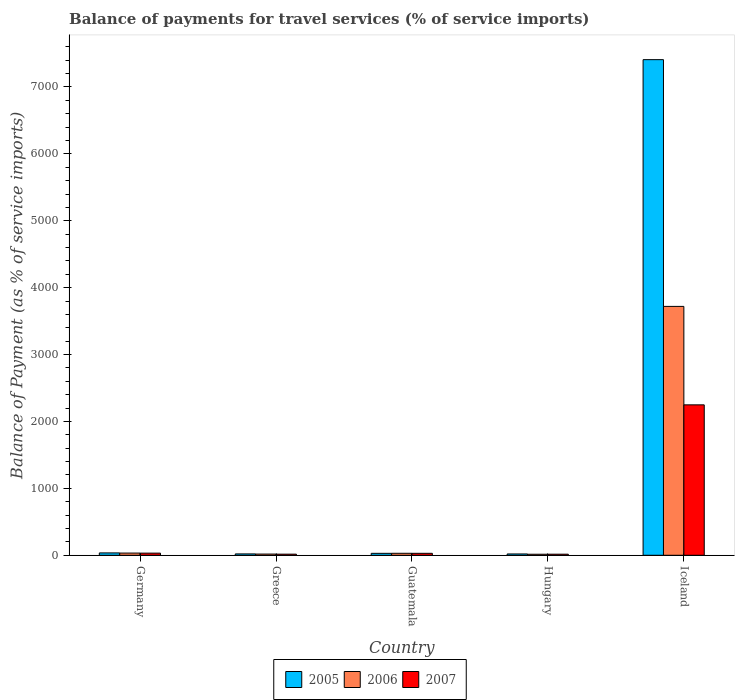How many different coloured bars are there?
Your response must be concise. 3. Are the number of bars per tick equal to the number of legend labels?
Make the answer very short. Yes. How many bars are there on the 1st tick from the right?
Your response must be concise. 3. What is the label of the 3rd group of bars from the left?
Your response must be concise. Guatemala. What is the balance of payments for travel services in 2005 in Germany?
Ensure brevity in your answer.  35.35. Across all countries, what is the maximum balance of payments for travel services in 2005?
Your response must be concise. 7408.18. Across all countries, what is the minimum balance of payments for travel services in 2005?
Your answer should be very brief. 19.74. In which country was the balance of payments for travel services in 2005 minimum?
Your answer should be very brief. Hungary. What is the total balance of payments for travel services in 2007 in the graph?
Your answer should be compact. 2342.43. What is the difference between the balance of payments for travel services in 2005 in Hungary and that in Iceland?
Offer a terse response. -7388.44. What is the difference between the balance of payments for travel services in 2005 in Iceland and the balance of payments for travel services in 2006 in Germany?
Your response must be concise. 7375.24. What is the average balance of payments for travel services in 2006 per country?
Ensure brevity in your answer.  763.21. What is the difference between the balance of payments for travel services of/in 2007 and balance of payments for travel services of/in 2006 in Germany?
Give a very brief answer. -0.89. What is the ratio of the balance of payments for travel services in 2005 in Greece to that in Iceland?
Provide a short and direct response. 0. Is the difference between the balance of payments for travel services in 2007 in Germany and Guatemala greater than the difference between the balance of payments for travel services in 2006 in Germany and Guatemala?
Keep it short and to the point. No. What is the difference between the highest and the second highest balance of payments for travel services in 2007?
Give a very brief answer. 2216.37. What is the difference between the highest and the lowest balance of payments for travel services in 2007?
Make the answer very short. 2232.34. What does the 2nd bar from the left in Germany represents?
Your answer should be compact. 2006. Is it the case that in every country, the sum of the balance of payments for travel services in 2006 and balance of payments for travel services in 2005 is greater than the balance of payments for travel services in 2007?
Ensure brevity in your answer.  Yes. How many bars are there?
Ensure brevity in your answer.  15. Are all the bars in the graph horizontal?
Make the answer very short. No. How many countries are there in the graph?
Offer a very short reply. 5. Are the values on the major ticks of Y-axis written in scientific E-notation?
Offer a terse response. No. Does the graph contain any zero values?
Your answer should be very brief. No. How many legend labels are there?
Offer a very short reply. 3. What is the title of the graph?
Make the answer very short. Balance of payments for travel services (% of service imports). What is the label or title of the X-axis?
Keep it short and to the point. Country. What is the label or title of the Y-axis?
Provide a short and direct response. Balance of Payment (as % of service imports). What is the Balance of Payment (as % of service imports) in 2005 in Germany?
Your answer should be compact. 35.35. What is the Balance of Payment (as % of service imports) of 2006 in Germany?
Provide a succinct answer. 32.95. What is the Balance of Payment (as % of service imports) in 2007 in Germany?
Ensure brevity in your answer.  32.05. What is the Balance of Payment (as % of service imports) of 2005 in Greece?
Provide a succinct answer. 20.38. What is the Balance of Payment (as % of service imports) of 2006 in Greece?
Your response must be concise. 17.89. What is the Balance of Payment (as % of service imports) in 2007 in Greece?
Ensure brevity in your answer.  16.62. What is the Balance of Payment (as % of service imports) in 2005 in Guatemala?
Keep it short and to the point. 29.03. What is the Balance of Payment (as % of service imports) of 2006 in Guatemala?
Your response must be concise. 29.72. What is the Balance of Payment (as % of service imports) in 2007 in Guatemala?
Offer a terse response. 29.26. What is the Balance of Payment (as % of service imports) in 2005 in Hungary?
Your answer should be very brief. 19.74. What is the Balance of Payment (as % of service imports) in 2006 in Hungary?
Provide a short and direct response. 15.47. What is the Balance of Payment (as % of service imports) of 2007 in Hungary?
Make the answer very short. 16.08. What is the Balance of Payment (as % of service imports) of 2005 in Iceland?
Provide a short and direct response. 7408.18. What is the Balance of Payment (as % of service imports) in 2006 in Iceland?
Keep it short and to the point. 3720.04. What is the Balance of Payment (as % of service imports) of 2007 in Iceland?
Give a very brief answer. 2248.42. Across all countries, what is the maximum Balance of Payment (as % of service imports) of 2005?
Your answer should be very brief. 7408.18. Across all countries, what is the maximum Balance of Payment (as % of service imports) of 2006?
Provide a succinct answer. 3720.04. Across all countries, what is the maximum Balance of Payment (as % of service imports) in 2007?
Provide a short and direct response. 2248.42. Across all countries, what is the minimum Balance of Payment (as % of service imports) in 2005?
Ensure brevity in your answer.  19.74. Across all countries, what is the minimum Balance of Payment (as % of service imports) in 2006?
Your response must be concise. 15.47. Across all countries, what is the minimum Balance of Payment (as % of service imports) of 2007?
Your answer should be compact. 16.08. What is the total Balance of Payment (as % of service imports) of 2005 in the graph?
Your answer should be compact. 7512.68. What is the total Balance of Payment (as % of service imports) of 2006 in the graph?
Offer a very short reply. 3816.07. What is the total Balance of Payment (as % of service imports) in 2007 in the graph?
Offer a very short reply. 2342.43. What is the difference between the Balance of Payment (as % of service imports) of 2005 in Germany and that in Greece?
Your answer should be very brief. 14.97. What is the difference between the Balance of Payment (as % of service imports) in 2006 in Germany and that in Greece?
Offer a terse response. 15.06. What is the difference between the Balance of Payment (as % of service imports) in 2007 in Germany and that in Greece?
Your response must be concise. 15.44. What is the difference between the Balance of Payment (as % of service imports) in 2005 in Germany and that in Guatemala?
Provide a succinct answer. 6.32. What is the difference between the Balance of Payment (as % of service imports) in 2006 in Germany and that in Guatemala?
Provide a short and direct response. 3.23. What is the difference between the Balance of Payment (as % of service imports) of 2007 in Germany and that in Guatemala?
Provide a succinct answer. 2.8. What is the difference between the Balance of Payment (as % of service imports) of 2005 in Germany and that in Hungary?
Provide a short and direct response. 15.61. What is the difference between the Balance of Payment (as % of service imports) in 2006 in Germany and that in Hungary?
Make the answer very short. 17.47. What is the difference between the Balance of Payment (as % of service imports) in 2007 in Germany and that in Hungary?
Offer a terse response. 15.97. What is the difference between the Balance of Payment (as % of service imports) of 2005 in Germany and that in Iceland?
Provide a succinct answer. -7372.83. What is the difference between the Balance of Payment (as % of service imports) in 2006 in Germany and that in Iceland?
Provide a short and direct response. -3687.1. What is the difference between the Balance of Payment (as % of service imports) of 2007 in Germany and that in Iceland?
Your response must be concise. -2216.37. What is the difference between the Balance of Payment (as % of service imports) in 2005 in Greece and that in Guatemala?
Keep it short and to the point. -8.65. What is the difference between the Balance of Payment (as % of service imports) in 2006 in Greece and that in Guatemala?
Your answer should be compact. -11.83. What is the difference between the Balance of Payment (as % of service imports) in 2007 in Greece and that in Guatemala?
Give a very brief answer. -12.64. What is the difference between the Balance of Payment (as % of service imports) in 2005 in Greece and that in Hungary?
Your answer should be compact. 0.64. What is the difference between the Balance of Payment (as % of service imports) of 2006 in Greece and that in Hungary?
Keep it short and to the point. 2.41. What is the difference between the Balance of Payment (as % of service imports) in 2007 in Greece and that in Hungary?
Your answer should be compact. 0.54. What is the difference between the Balance of Payment (as % of service imports) in 2005 in Greece and that in Iceland?
Your response must be concise. -7387.81. What is the difference between the Balance of Payment (as % of service imports) in 2006 in Greece and that in Iceland?
Your response must be concise. -3702.16. What is the difference between the Balance of Payment (as % of service imports) of 2007 in Greece and that in Iceland?
Your answer should be compact. -2231.81. What is the difference between the Balance of Payment (as % of service imports) in 2005 in Guatemala and that in Hungary?
Provide a short and direct response. 9.29. What is the difference between the Balance of Payment (as % of service imports) of 2006 in Guatemala and that in Hungary?
Provide a short and direct response. 14.24. What is the difference between the Balance of Payment (as % of service imports) of 2007 in Guatemala and that in Hungary?
Offer a terse response. 13.18. What is the difference between the Balance of Payment (as % of service imports) in 2005 in Guatemala and that in Iceland?
Keep it short and to the point. -7379.15. What is the difference between the Balance of Payment (as % of service imports) in 2006 in Guatemala and that in Iceland?
Keep it short and to the point. -3690.32. What is the difference between the Balance of Payment (as % of service imports) in 2007 in Guatemala and that in Iceland?
Provide a short and direct response. -2219.17. What is the difference between the Balance of Payment (as % of service imports) in 2005 in Hungary and that in Iceland?
Offer a terse response. -7388.44. What is the difference between the Balance of Payment (as % of service imports) in 2006 in Hungary and that in Iceland?
Offer a terse response. -3704.57. What is the difference between the Balance of Payment (as % of service imports) in 2007 in Hungary and that in Iceland?
Your answer should be very brief. -2232.34. What is the difference between the Balance of Payment (as % of service imports) in 2005 in Germany and the Balance of Payment (as % of service imports) in 2006 in Greece?
Your response must be concise. 17.46. What is the difference between the Balance of Payment (as % of service imports) in 2005 in Germany and the Balance of Payment (as % of service imports) in 2007 in Greece?
Give a very brief answer. 18.73. What is the difference between the Balance of Payment (as % of service imports) in 2006 in Germany and the Balance of Payment (as % of service imports) in 2007 in Greece?
Give a very brief answer. 16.33. What is the difference between the Balance of Payment (as % of service imports) of 2005 in Germany and the Balance of Payment (as % of service imports) of 2006 in Guatemala?
Provide a succinct answer. 5.63. What is the difference between the Balance of Payment (as % of service imports) of 2005 in Germany and the Balance of Payment (as % of service imports) of 2007 in Guatemala?
Keep it short and to the point. 6.09. What is the difference between the Balance of Payment (as % of service imports) in 2006 in Germany and the Balance of Payment (as % of service imports) in 2007 in Guatemala?
Ensure brevity in your answer.  3.69. What is the difference between the Balance of Payment (as % of service imports) in 2005 in Germany and the Balance of Payment (as % of service imports) in 2006 in Hungary?
Give a very brief answer. 19.88. What is the difference between the Balance of Payment (as % of service imports) in 2005 in Germany and the Balance of Payment (as % of service imports) in 2007 in Hungary?
Keep it short and to the point. 19.27. What is the difference between the Balance of Payment (as % of service imports) of 2006 in Germany and the Balance of Payment (as % of service imports) of 2007 in Hungary?
Your response must be concise. 16.87. What is the difference between the Balance of Payment (as % of service imports) of 2005 in Germany and the Balance of Payment (as % of service imports) of 2006 in Iceland?
Offer a very short reply. -3684.69. What is the difference between the Balance of Payment (as % of service imports) of 2005 in Germany and the Balance of Payment (as % of service imports) of 2007 in Iceland?
Your answer should be compact. -2213.07. What is the difference between the Balance of Payment (as % of service imports) of 2006 in Germany and the Balance of Payment (as % of service imports) of 2007 in Iceland?
Provide a succinct answer. -2215.48. What is the difference between the Balance of Payment (as % of service imports) of 2005 in Greece and the Balance of Payment (as % of service imports) of 2006 in Guatemala?
Offer a terse response. -9.34. What is the difference between the Balance of Payment (as % of service imports) in 2005 in Greece and the Balance of Payment (as % of service imports) in 2007 in Guatemala?
Your answer should be very brief. -8.88. What is the difference between the Balance of Payment (as % of service imports) of 2006 in Greece and the Balance of Payment (as % of service imports) of 2007 in Guatemala?
Give a very brief answer. -11.37. What is the difference between the Balance of Payment (as % of service imports) in 2005 in Greece and the Balance of Payment (as % of service imports) in 2006 in Hungary?
Your answer should be very brief. 4.9. What is the difference between the Balance of Payment (as % of service imports) in 2005 in Greece and the Balance of Payment (as % of service imports) in 2007 in Hungary?
Give a very brief answer. 4.3. What is the difference between the Balance of Payment (as % of service imports) of 2006 in Greece and the Balance of Payment (as % of service imports) of 2007 in Hungary?
Make the answer very short. 1.81. What is the difference between the Balance of Payment (as % of service imports) of 2005 in Greece and the Balance of Payment (as % of service imports) of 2006 in Iceland?
Keep it short and to the point. -3699.67. What is the difference between the Balance of Payment (as % of service imports) in 2005 in Greece and the Balance of Payment (as % of service imports) in 2007 in Iceland?
Give a very brief answer. -2228.05. What is the difference between the Balance of Payment (as % of service imports) of 2006 in Greece and the Balance of Payment (as % of service imports) of 2007 in Iceland?
Your answer should be very brief. -2230.54. What is the difference between the Balance of Payment (as % of service imports) of 2005 in Guatemala and the Balance of Payment (as % of service imports) of 2006 in Hungary?
Provide a succinct answer. 13.55. What is the difference between the Balance of Payment (as % of service imports) of 2005 in Guatemala and the Balance of Payment (as % of service imports) of 2007 in Hungary?
Your answer should be very brief. 12.95. What is the difference between the Balance of Payment (as % of service imports) of 2006 in Guatemala and the Balance of Payment (as % of service imports) of 2007 in Hungary?
Ensure brevity in your answer.  13.64. What is the difference between the Balance of Payment (as % of service imports) in 2005 in Guatemala and the Balance of Payment (as % of service imports) in 2006 in Iceland?
Your response must be concise. -3691.01. What is the difference between the Balance of Payment (as % of service imports) of 2005 in Guatemala and the Balance of Payment (as % of service imports) of 2007 in Iceland?
Your response must be concise. -2219.39. What is the difference between the Balance of Payment (as % of service imports) of 2006 in Guatemala and the Balance of Payment (as % of service imports) of 2007 in Iceland?
Provide a succinct answer. -2218.71. What is the difference between the Balance of Payment (as % of service imports) in 2005 in Hungary and the Balance of Payment (as % of service imports) in 2006 in Iceland?
Your response must be concise. -3700.3. What is the difference between the Balance of Payment (as % of service imports) in 2005 in Hungary and the Balance of Payment (as % of service imports) in 2007 in Iceland?
Offer a terse response. -2228.68. What is the difference between the Balance of Payment (as % of service imports) in 2006 in Hungary and the Balance of Payment (as % of service imports) in 2007 in Iceland?
Offer a terse response. -2232.95. What is the average Balance of Payment (as % of service imports) of 2005 per country?
Your response must be concise. 1502.54. What is the average Balance of Payment (as % of service imports) of 2006 per country?
Your response must be concise. 763.21. What is the average Balance of Payment (as % of service imports) of 2007 per country?
Give a very brief answer. 468.49. What is the difference between the Balance of Payment (as % of service imports) of 2005 and Balance of Payment (as % of service imports) of 2006 in Germany?
Provide a succinct answer. 2.41. What is the difference between the Balance of Payment (as % of service imports) of 2005 and Balance of Payment (as % of service imports) of 2007 in Germany?
Keep it short and to the point. 3.3. What is the difference between the Balance of Payment (as % of service imports) in 2006 and Balance of Payment (as % of service imports) in 2007 in Germany?
Make the answer very short. 0.89. What is the difference between the Balance of Payment (as % of service imports) of 2005 and Balance of Payment (as % of service imports) of 2006 in Greece?
Keep it short and to the point. 2.49. What is the difference between the Balance of Payment (as % of service imports) in 2005 and Balance of Payment (as % of service imports) in 2007 in Greece?
Provide a short and direct response. 3.76. What is the difference between the Balance of Payment (as % of service imports) of 2006 and Balance of Payment (as % of service imports) of 2007 in Greece?
Provide a succinct answer. 1.27. What is the difference between the Balance of Payment (as % of service imports) in 2005 and Balance of Payment (as % of service imports) in 2006 in Guatemala?
Your answer should be very brief. -0.69. What is the difference between the Balance of Payment (as % of service imports) of 2005 and Balance of Payment (as % of service imports) of 2007 in Guatemala?
Provide a short and direct response. -0.23. What is the difference between the Balance of Payment (as % of service imports) of 2006 and Balance of Payment (as % of service imports) of 2007 in Guatemala?
Your response must be concise. 0.46. What is the difference between the Balance of Payment (as % of service imports) of 2005 and Balance of Payment (as % of service imports) of 2006 in Hungary?
Ensure brevity in your answer.  4.27. What is the difference between the Balance of Payment (as % of service imports) of 2005 and Balance of Payment (as % of service imports) of 2007 in Hungary?
Offer a very short reply. 3.66. What is the difference between the Balance of Payment (as % of service imports) in 2006 and Balance of Payment (as % of service imports) in 2007 in Hungary?
Your response must be concise. -0.61. What is the difference between the Balance of Payment (as % of service imports) of 2005 and Balance of Payment (as % of service imports) of 2006 in Iceland?
Give a very brief answer. 3688.14. What is the difference between the Balance of Payment (as % of service imports) of 2005 and Balance of Payment (as % of service imports) of 2007 in Iceland?
Ensure brevity in your answer.  5159.76. What is the difference between the Balance of Payment (as % of service imports) of 2006 and Balance of Payment (as % of service imports) of 2007 in Iceland?
Make the answer very short. 1471.62. What is the ratio of the Balance of Payment (as % of service imports) in 2005 in Germany to that in Greece?
Ensure brevity in your answer.  1.73. What is the ratio of the Balance of Payment (as % of service imports) in 2006 in Germany to that in Greece?
Offer a terse response. 1.84. What is the ratio of the Balance of Payment (as % of service imports) in 2007 in Germany to that in Greece?
Your response must be concise. 1.93. What is the ratio of the Balance of Payment (as % of service imports) in 2005 in Germany to that in Guatemala?
Your answer should be very brief. 1.22. What is the ratio of the Balance of Payment (as % of service imports) of 2006 in Germany to that in Guatemala?
Your answer should be compact. 1.11. What is the ratio of the Balance of Payment (as % of service imports) of 2007 in Germany to that in Guatemala?
Your response must be concise. 1.1. What is the ratio of the Balance of Payment (as % of service imports) of 2005 in Germany to that in Hungary?
Your answer should be compact. 1.79. What is the ratio of the Balance of Payment (as % of service imports) in 2006 in Germany to that in Hungary?
Provide a short and direct response. 2.13. What is the ratio of the Balance of Payment (as % of service imports) in 2007 in Germany to that in Hungary?
Your response must be concise. 1.99. What is the ratio of the Balance of Payment (as % of service imports) of 2005 in Germany to that in Iceland?
Offer a terse response. 0. What is the ratio of the Balance of Payment (as % of service imports) of 2006 in Germany to that in Iceland?
Your answer should be very brief. 0.01. What is the ratio of the Balance of Payment (as % of service imports) in 2007 in Germany to that in Iceland?
Ensure brevity in your answer.  0.01. What is the ratio of the Balance of Payment (as % of service imports) of 2005 in Greece to that in Guatemala?
Ensure brevity in your answer.  0.7. What is the ratio of the Balance of Payment (as % of service imports) in 2006 in Greece to that in Guatemala?
Provide a short and direct response. 0.6. What is the ratio of the Balance of Payment (as % of service imports) in 2007 in Greece to that in Guatemala?
Your answer should be compact. 0.57. What is the ratio of the Balance of Payment (as % of service imports) of 2005 in Greece to that in Hungary?
Provide a succinct answer. 1.03. What is the ratio of the Balance of Payment (as % of service imports) in 2006 in Greece to that in Hungary?
Your answer should be very brief. 1.16. What is the ratio of the Balance of Payment (as % of service imports) in 2005 in Greece to that in Iceland?
Offer a very short reply. 0. What is the ratio of the Balance of Payment (as % of service imports) of 2006 in Greece to that in Iceland?
Ensure brevity in your answer.  0. What is the ratio of the Balance of Payment (as % of service imports) of 2007 in Greece to that in Iceland?
Ensure brevity in your answer.  0.01. What is the ratio of the Balance of Payment (as % of service imports) in 2005 in Guatemala to that in Hungary?
Make the answer very short. 1.47. What is the ratio of the Balance of Payment (as % of service imports) in 2006 in Guatemala to that in Hungary?
Make the answer very short. 1.92. What is the ratio of the Balance of Payment (as % of service imports) of 2007 in Guatemala to that in Hungary?
Give a very brief answer. 1.82. What is the ratio of the Balance of Payment (as % of service imports) of 2005 in Guatemala to that in Iceland?
Provide a short and direct response. 0. What is the ratio of the Balance of Payment (as % of service imports) in 2006 in Guatemala to that in Iceland?
Give a very brief answer. 0.01. What is the ratio of the Balance of Payment (as % of service imports) of 2007 in Guatemala to that in Iceland?
Your answer should be compact. 0.01. What is the ratio of the Balance of Payment (as % of service imports) of 2005 in Hungary to that in Iceland?
Ensure brevity in your answer.  0. What is the ratio of the Balance of Payment (as % of service imports) of 2006 in Hungary to that in Iceland?
Ensure brevity in your answer.  0. What is the ratio of the Balance of Payment (as % of service imports) of 2007 in Hungary to that in Iceland?
Your answer should be very brief. 0.01. What is the difference between the highest and the second highest Balance of Payment (as % of service imports) in 2005?
Ensure brevity in your answer.  7372.83. What is the difference between the highest and the second highest Balance of Payment (as % of service imports) of 2006?
Your response must be concise. 3687.1. What is the difference between the highest and the second highest Balance of Payment (as % of service imports) in 2007?
Your response must be concise. 2216.37. What is the difference between the highest and the lowest Balance of Payment (as % of service imports) in 2005?
Keep it short and to the point. 7388.44. What is the difference between the highest and the lowest Balance of Payment (as % of service imports) of 2006?
Your answer should be very brief. 3704.57. What is the difference between the highest and the lowest Balance of Payment (as % of service imports) in 2007?
Make the answer very short. 2232.34. 